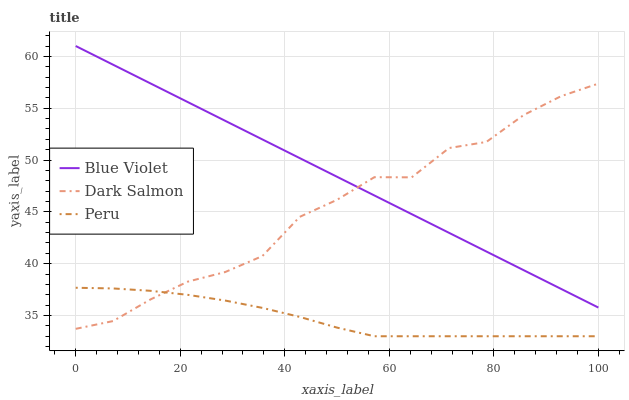Does Peru have the minimum area under the curve?
Answer yes or no. Yes. Does Blue Violet have the maximum area under the curve?
Answer yes or no. Yes. Does Dark Salmon have the minimum area under the curve?
Answer yes or no. No. Does Dark Salmon have the maximum area under the curve?
Answer yes or no. No. Is Blue Violet the smoothest?
Answer yes or no. Yes. Is Dark Salmon the roughest?
Answer yes or no. Yes. Is Dark Salmon the smoothest?
Answer yes or no. No. Is Blue Violet the roughest?
Answer yes or no. No. Does Dark Salmon have the lowest value?
Answer yes or no. No. Does Blue Violet have the highest value?
Answer yes or no. Yes. Does Dark Salmon have the highest value?
Answer yes or no. No. Is Peru less than Blue Violet?
Answer yes or no. Yes. Is Blue Violet greater than Peru?
Answer yes or no. Yes. Does Blue Violet intersect Dark Salmon?
Answer yes or no. Yes. Is Blue Violet less than Dark Salmon?
Answer yes or no. No. Is Blue Violet greater than Dark Salmon?
Answer yes or no. No. Does Peru intersect Blue Violet?
Answer yes or no. No. 